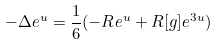Convert formula to latex. <formula><loc_0><loc_0><loc_500><loc_500>- \Delta e ^ { u } = \frac { 1 } { 6 } ( - R e ^ { u } + R [ g ] e ^ { 3 u } )</formula> 